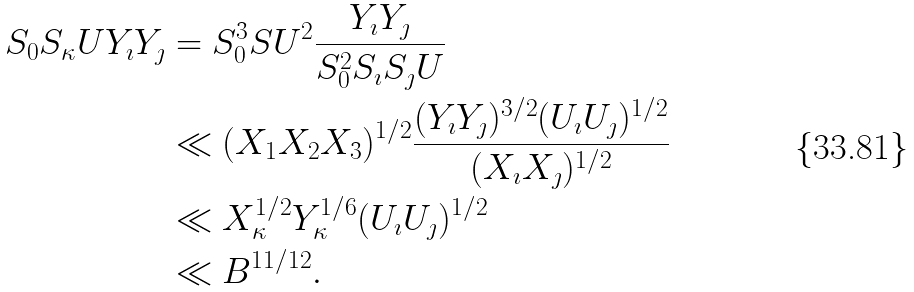Convert formula to latex. <formula><loc_0><loc_0><loc_500><loc_500>S _ { 0 } S _ { \kappa } U Y _ { \imath } Y _ { \jmath } & = S _ { 0 } ^ { 3 } S U ^ { 2 } \frac { Y _ { \imath } Y _ { \jmath } } { S _ { 0 } ^ { 2 } S _ { \imath } S _ { \jmath } U } \\ & \ll ( X _ { 1 } X _ { 2 } X _ { 3 } ) ^ { 1 / 2 } \frac { ( Y _ { \imath } Y _ { \jmath } ) ^ { 3 / 2 } ( U _ { \imath } U _ { \jmath } ) ^ { 1 / 2 } } { ( X _ { \imath } X _ { \jmath } ) ^ { 1 / 2 } } \\ & \ll X _ { \kappa } ^ { 1 / 2 } Y _ { \kappa } ^ { 1 / 6 } ( U _ { \imath } U _ { \jmath } ) ^ { 1 / 2 } \\ & \ll B ^ { 1 1 / 1 2 } .</formula> 